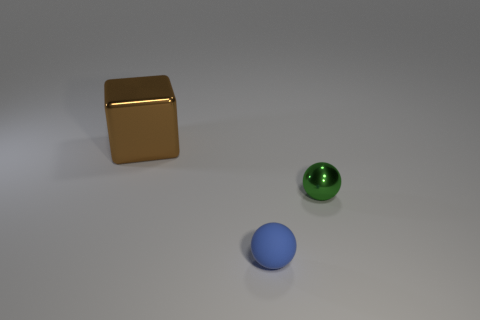Is the size of the sphere that is left of the green sphere the same as the metal ball?
Provide a short and direct response. Yes. Is there any other thing that has the same size as the brown object?
Offer a terse response. No. Is the number of brown metal blocks that are in front of the metal sphere the same as the number of tiny spheres that are behind the blue thing?
Give a very brief answer. No. How big is the shiny object that is to the left of the small blue object?
Offer a terse response. Large. Are there any other things that are the same shape as the tiny blue matte thing?
Give a very brief answer. Yes. Is the number of large cubes behind the blue rubber ball the same as the number of tiny blue metallic balls?
Make the answer very short. No. Are there any green balls left of the rubber ball?
Your answer should be very brief. No. Do the brown thing and the shiny object in front of the large cube have the same shape?
Offer a very short reply. No. What is the color of the ball that is made of the same material as the brown object?
Your response must be concise. Green. What is the color of the metal block?
Provide a succinct answer. Brown. 